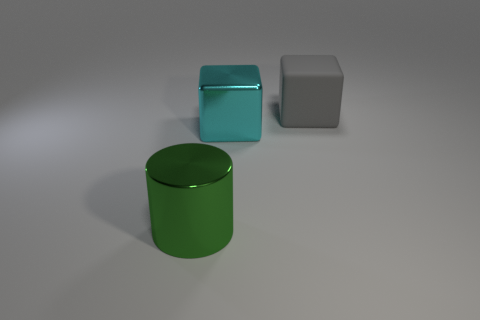Subtract all cyan blocks. How many blocks are left? 1 Subtract all blocks. How many objects are left? 1 Add 2 large red metallic cylinders. How many objects exist? 5 Subtract 1 cylinders. How many cylinders are left? 0 Subtract 0 brown blocks. How many objects are left? 3 Subtract all blue cylinders. Subtract all cyan spheres. How many cylinders are left? 1 Subtract all gray cubes. How many brown cylinders are left? 0 Subtract all large blue rubber cylinders. Subtract all cyan metallic things. How many objects are left? 2 Add 1 large cubes. How many large cubes are left? 3 Add 1 green rubber spheres. How many green rubber spheres exist? 1 